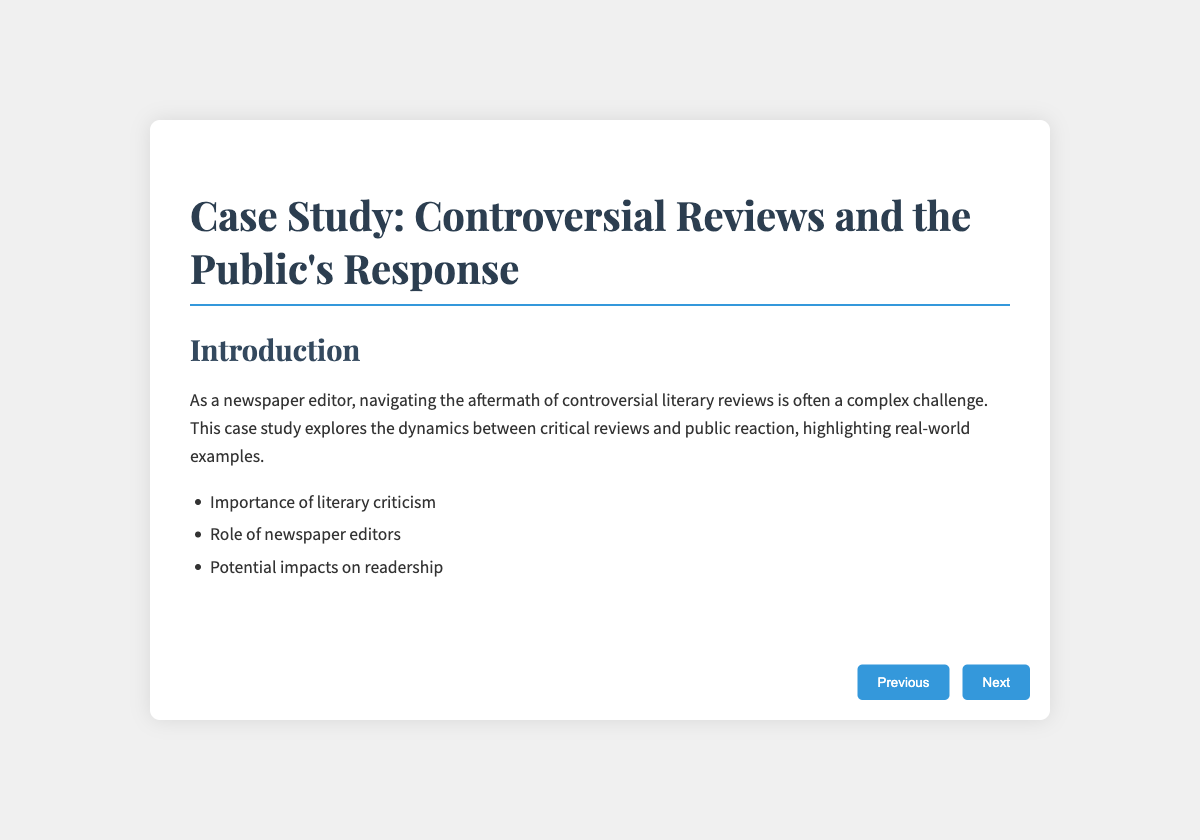What is the title of the case study? The title of the case study is presented in the introduction slide.
Answer: Case Study: Controversial Reviews and the Public's Response Who is the author of 'American Dirt'? The author of 'American Dirt' is mentioned in the related case study slide.
Answer: Jeanine Cummins What aspect of 'Infinite Jest' generated mixed reviews? The case study discusses the complexity of 'Infinite Jest' that contributed to its mixed reviews.
Answer: Complex structure and narrative style What does the slide on "Public Response Mechanisms" mention as an immediate reaction? The slide lists various mechanisms for public response, including a specific one that involves social media.
Answer: Social Media Outcry What is one strategy for newspaper editors mentioned in the document? The strategies for newspaper editors are outlined in the specific strategies slide.
Answer: Balanced Coverage 